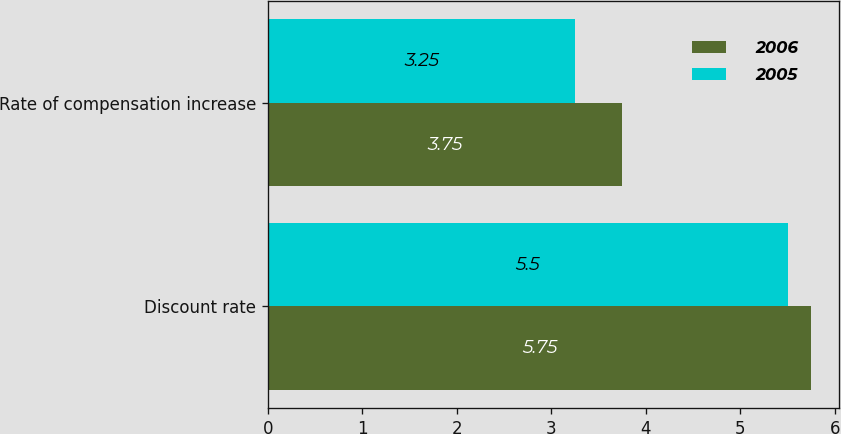Convert chart. <chart><loc_0><loc_0><loc_500><loc_500><stacked_bar_chart><ecel><fcel>Discount rate<fcel>Rate of compensation increase<nl><fcel>2006<fcel>5.75<fcel>3.75<nl><fcel>2005<fcel>5.5<fcel>3.25<nl></chart> 